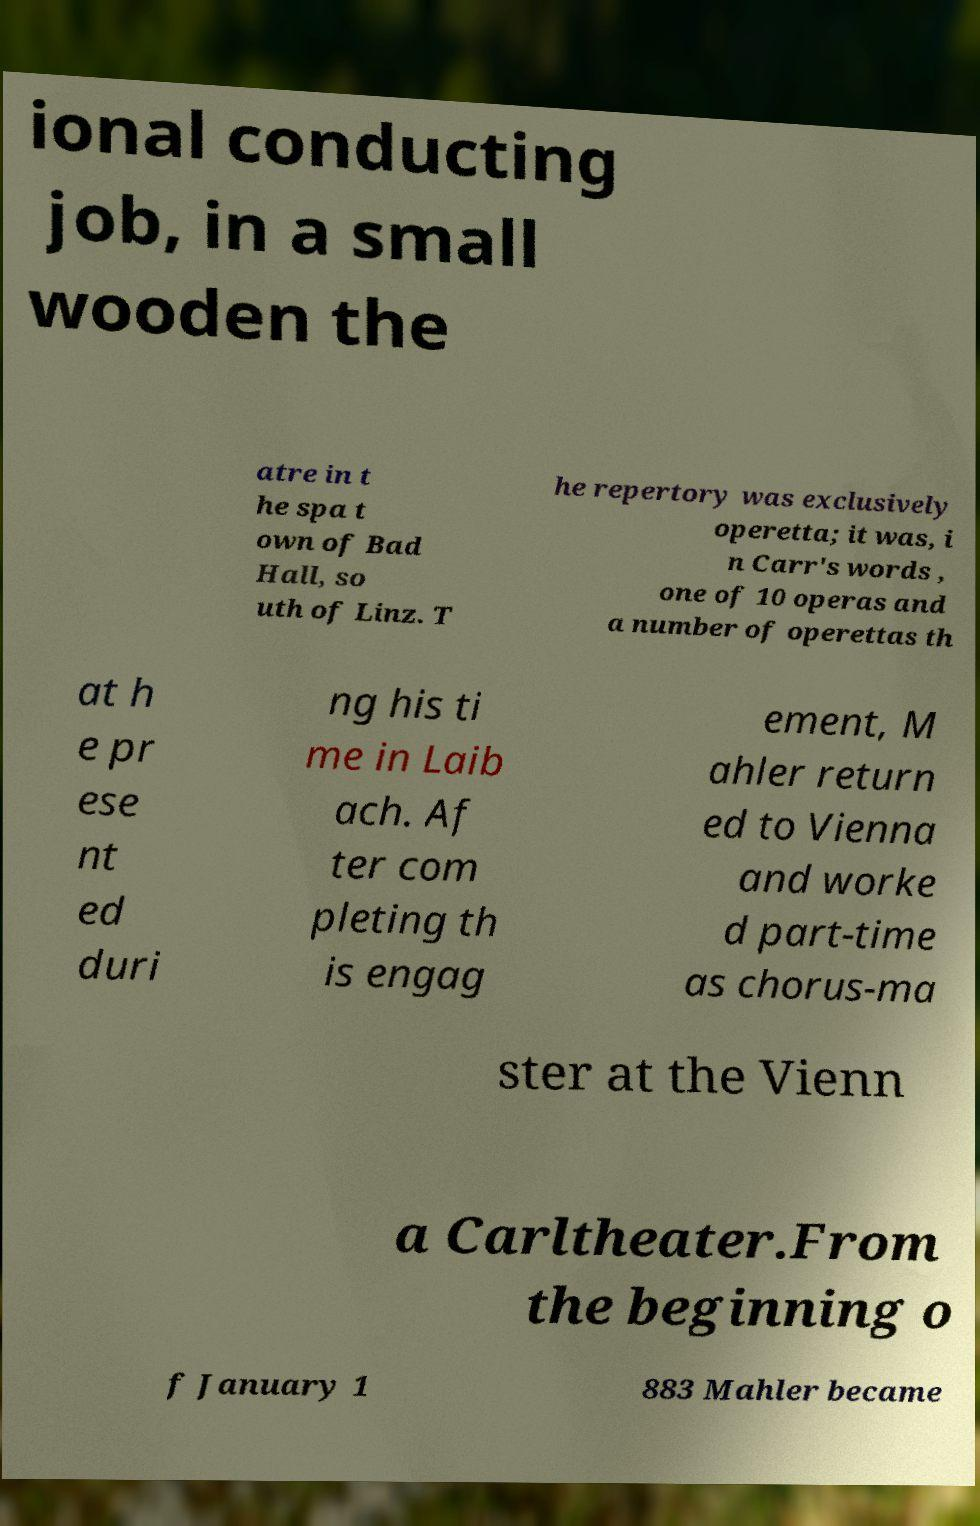I need the written content from this picture converted into text. Can you do that? ional conducting job, in a small wooden the atre in t he spa t own of Bad Hall, so uth of Linz. T he repertory was exclusively operetta; it was, i n Carr's words , one of 10 operas and a number of operettas th at h e pr ese nt ed duri ng his ti me in Laib ach. Af ter com pleting th is engag ement, M ahler return ed to Vienna and worke d part-time as chorus-ma ster at the Vienn a Carltheater.From the beginning o f January 1 883 Mahler became 